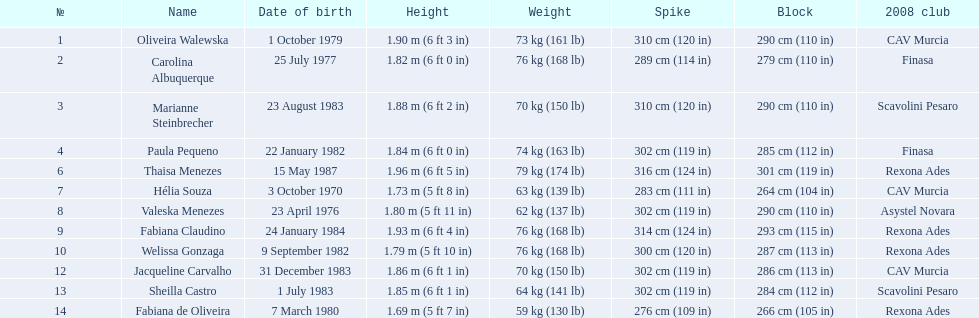Who played during the brazil at the 2008 summer olympics event? Oliveira Walewska, Carolina Albuquerque, Marianne Steinbrecher, Paula Pequeno, Thaisa Menezes, Hélia Souza, Valeska Menezes, Fabiana Claudino, Welissa Gonzaga, Jacqueline Carvalho, Sheilla Castro, Fabiana de Oliveira. And what was the recorded height of each player? 1.90 m (6 ft 3 in), 1.82 m (6 ft 0 in), 1.88 m (6 ft 2 in), 1.84 m (6 ft 0 in), 1.96 m (6 ft 5 in), 1.73 m (5 ft 8 in), 1.80 m (5 ft 11 in), 1.93 m (6 ft 4 in), 1.79 m (5 ft 10 in), 1.86 m (6 ft 1 in), 1.85 m (6 ft 1 in), 1.69 m (5 ft 7 in). Of those, which player is the shortest? Fabiana de Oliveira. 